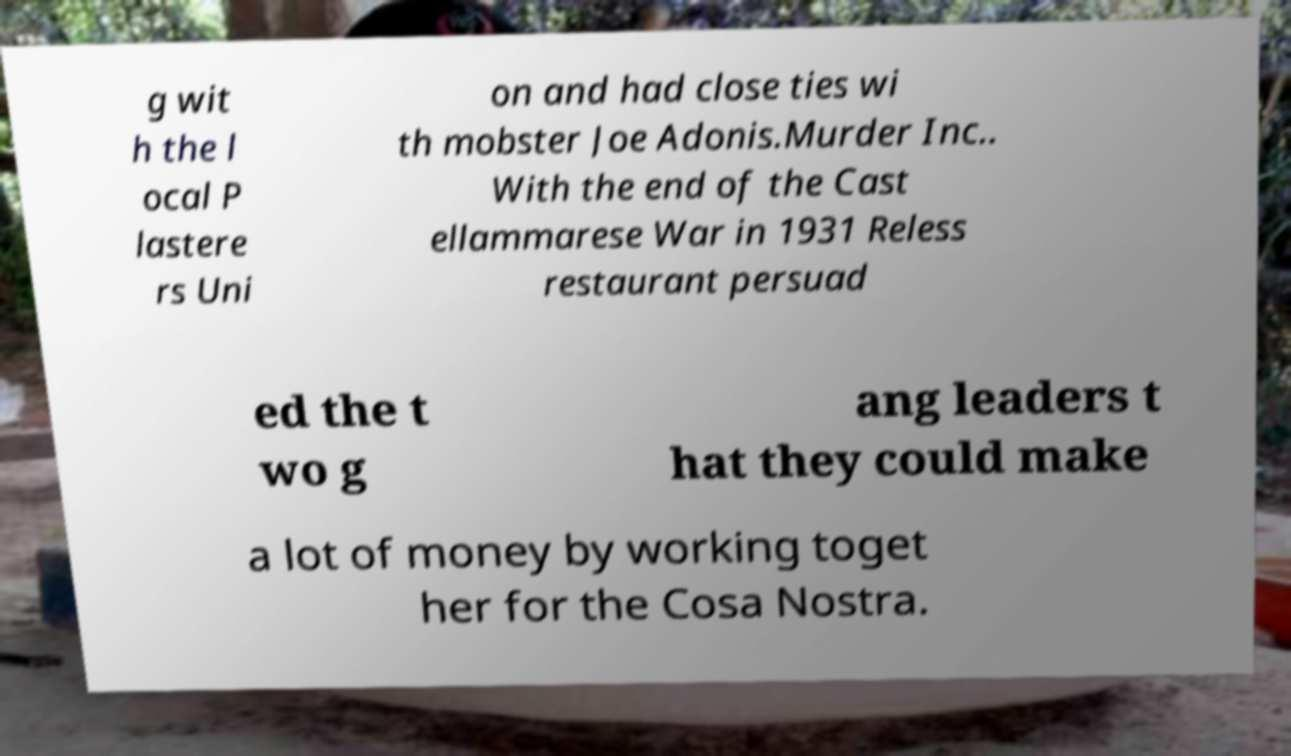For documentation purposes, I need the text within this image transcribed. Could you provide that? g wit h the l ocal P lastere rs Uni on and had close ties wi th mobster Joe Adonis.Murder Inc.. With the end of the Cast ellammarese War in 1931 Reless restaurant persuad ed the t wo g ang leaders t hat they could make a lot of money by working toget her for the Cosa Nostra. 